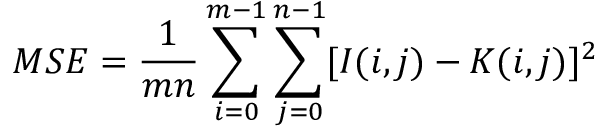Convert formula to latex. <formula><loc_0><loc_0><loc_500><loc_500>M S E = \frac { 1 } { m n } \sum _ { i = 0 } ^ { m - 1 } \sum _ { j = 0 } ^ { n - 1 } [ I ( i , j ) - K ( i , j ) ] ^ { 2 }</formula> 